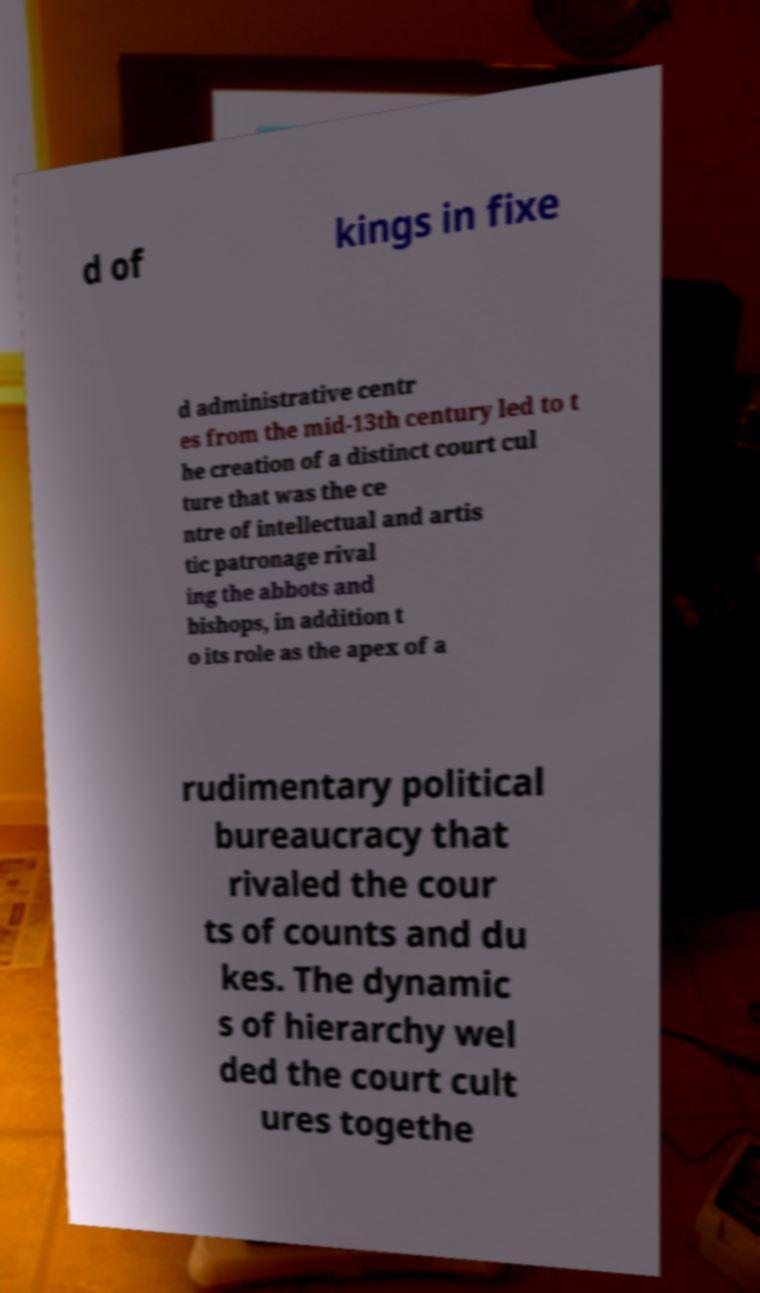Can you read and provide the text displayed in the image?This photo seems to have some interesting text. Can you extract and type it out for me? d of kings in fixe d administrative centr es from the mid-13th century led to t he creation of a distinct court cul ture that was the ce ntre of intellectual and artis tic patronage rival ing the abbots and bishops, in addition t o its role as the apex of a rudimentary political bureaucracy that rivaled the cour ts of counts and du kes. The dynamic s of hierarchy wel ded the court cult ures togethe 